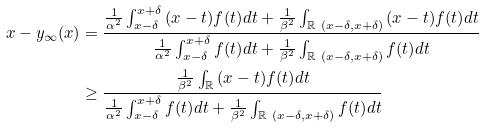<formula> <loc_0><loc_0><loc_500><loc_500>x - y _ { \infty } ( x ) & = \frac { \frac { 1 } { \alpha ^ { 2 } } \int _ { x - \delta } ^ { x + \delta } { ( x - t ) f ( t ) } d t + \frac { 1 } { \beta ^ { 2 } } \int _ { \mathbb { R } \ ( x - \delta , x + \delta ) } { ( x - t ) f ( t ) } d t } { \frac { 1 } { \alpha ^ { 2 } } \int _ { x - \delta } ^ { x + \delta } { f ( t ) } d t + \frac { 1 } { \beta ^ { 2 } } \int _ { \mathbb { R } \ ( x - \delta , x + \delta ) } { f ( t ) } d t } \\ & \geq \frac { \frac { 1 } { \beta ^ { 2 } } \int _ { \mathbb { R } } { ( x - t ) f ( t ) } d t } { \frac { 1 } { \alpha ^ { 2 } } \int _ { x - \delta } ^ { x + \delta } { f ( t ) } d t + \frac { 1 } { \beta ^ { 2 } } \int _ { \mathbb { R } \ ( x - \delta , x + \delta ) } { f ( t ) } d t }</formula> 